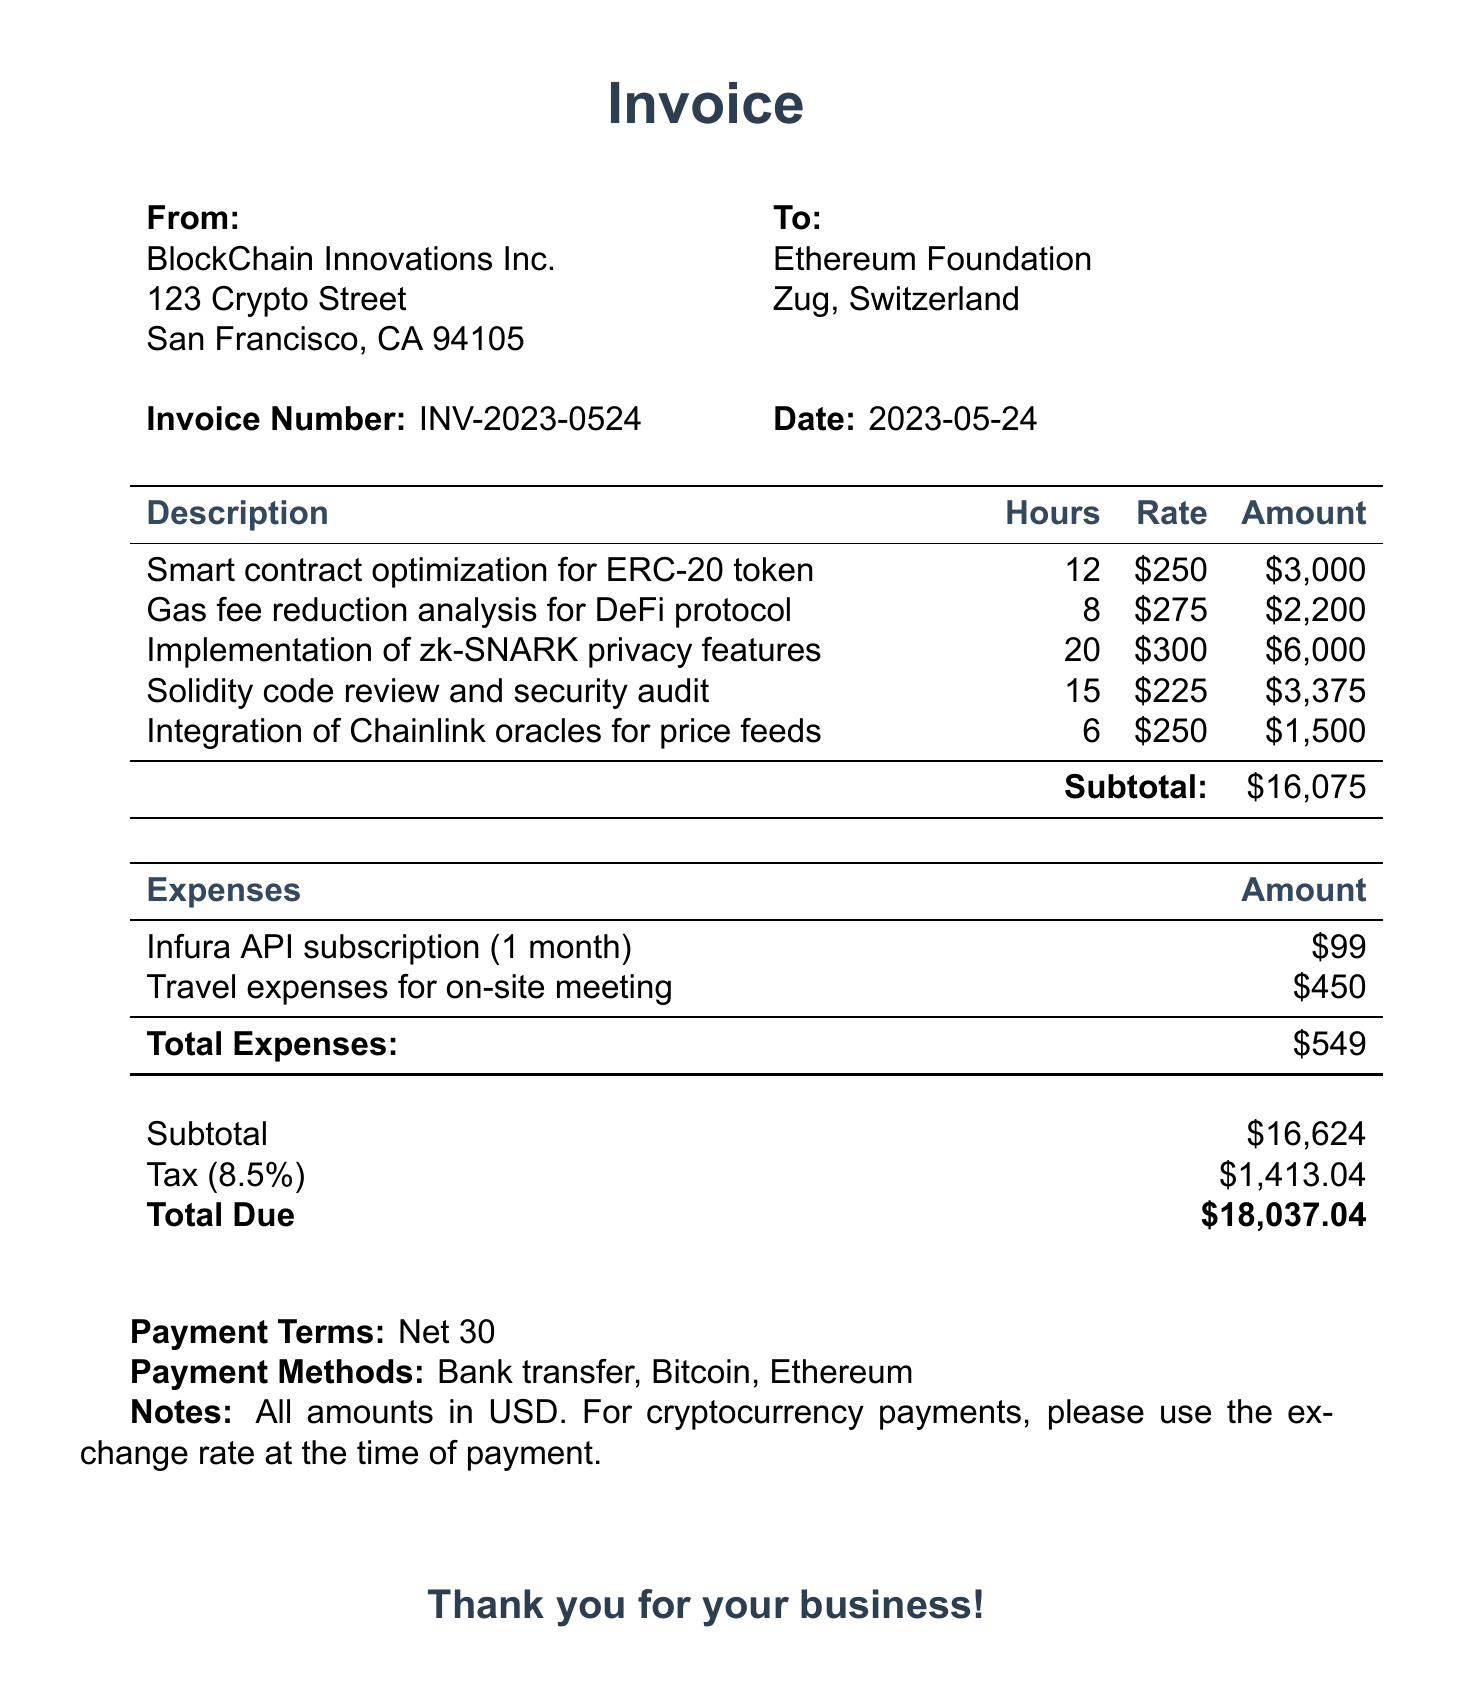what is the invoice number? The invoice number is provided at the top of the document, specifically labeled as "Invoice Number."
Answer: INV-2023-0524 who is the consultant? The document specifies the consultant's name in the "From" section, providing their business and address.
Answer: Alex Chen how many hours were spent on the integration of Chainlink oracles? The number of hours for each service is detailed in the "Description" table.
Answer: 6 what service required the most hours? The service with the highest hours worked is mentioned in the "Description" table, requiring comparison of the hours.
Answer: Implementation of zk-SNARK privacy features what is the total amount due? The total amount due is located in the final parts of the document, explicitly labeled as "Total Due."
Answer: $18,037.04 what is the tax rate applied to the invoice? The tax rate is clearly stated in the document, indicating the percentage applied.
Answer: 8.5% what is the payment term specified? Payment terms are mentioned clearly in the document, indicating the timeframe for payment.
Answer: Net 30 what are the acceptable payment methods? The payment methods are listed in a specific section of the document detailing how clients can proceed with payment.
Answer: Bank transfer, Bitcoin, Ethereum 